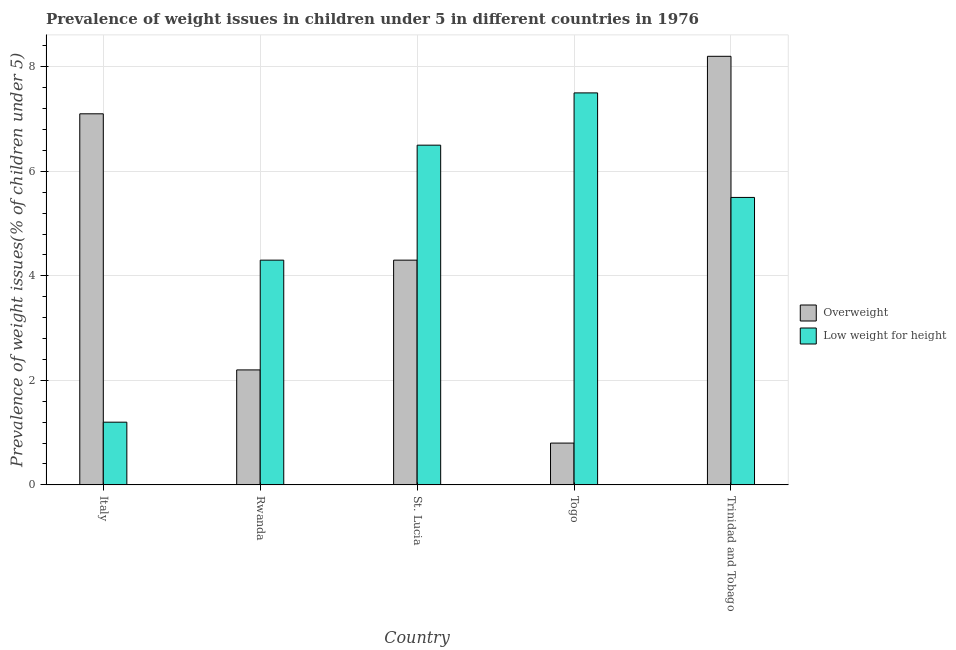How many groups of bars are there?
Ensure brevity in your answer.  5. Are the number of bars per tick equal to the number of legend labels?
Keep it short and to the point. Yes. Are the number of bars on each tick of the X-axis equal?
Your answer should be very brief. Yes. How many bars are there on the 4th tick from the right?
Your answer should be compact. 2. In how many cases, is the number of bars for a given country not equal to the number of legend labels?
Give a very brief answer. 0. Across all countries, what is the minimum percentage of overweight children?
Keep it short and to the point. 0.8. In which country was the percentage of overweight children maximum?
Ensure brevity in your answer.  Trinidad and Tobago. What is the total percentage of overweight children in the graph?
Provide a short and direct response. 22.6. What is the difference between the percentage of underweight children in Rwanda and that in Togo?
Ensure brevity in your answer.  -3.2. What is the difference between the percentage of underweight children in Italy and the percentage of overweight children in Trinidad and Tobago?
Make the answer very short. -7. What is the average percentage of underweight children per country?
Your response must be concise. 5. What is the difference between the percentage of overweight children and percentage of underweight children in Rwanda?
Provide a succinct answer. -2.1. What is the ratio of the percentage of overweight children in Italy to that in Trinidad and Tobago?
Your response must be concise. 0.87. Is the difference between the percentage of overweight children in Rwanda and Trinidad and Tobago greater than the difference between the percentage of underweight children in Rwanda and Trinidad and Tobago?
Your answer should be very brief. No. What is the difference between the highest and the second highest percentage of underweight children?
Provide a short and direct response. 1. What is the difference between the highest and the lowest percentage of overweight children?
Provide a short and direct response. 7.4. What does the 2nd bar from the left in Togo represents?
Ensure brevity in your answer.  Low weight for height. What does the 2nd bar from the right in Togo represents?
Your response must be concise. Overweight. Are all the bars in the graph horizontal?
Offer a terse response. No. How many countries are there in the graph?
Your answer should be compact. 5. Are the values on the major ticks of Y-axis written in scientific E-notation?
Provide a succinct answer. No. Does the graph contain grids?
Offer a very short reply. Yes. Where does the legend appear in the graph?
Offer a terse response. Center right. What is the title of the graph?
Provide a succinct answer. Prevalence of weight issues in children under 5 in different countries in 1976. Does "National Visitors" appear as one of the legend labels in the graph?
Your answer should be very brief. No. What is the label or title of the X-axis?
Your answer should be very brief. Country. What is the label or title of the Y-axis?
Provide a short and direct response. Prevalence of weight issues(% of children under 5). What is the Prevalence of weight issues(% of children under 5) in Overweight in Italy?
Your response must be concise. 7.1. What is the Prevalence of weight issues(% of children under 5) in Low weight for height in Italy?
Offer a terse response. 1.2. What is the Prevalence of weight issues(% of children under 5) of Overweight in Rwanda?
Keep it short and to the point. 2.2. What is the Prevalence of weight issues(% of children under 5) in Low weight for height in Rwanda?
Keep it short and to the point. 4.3. What is the Prevalence of weight issues(% of children under 5) of Overweight in St. Lucia?
Give a very brief answer. 4.3. What is the Prevalence of weight issues(% of children under 5) in Low weight for height in St. Lucia?
Your response must be concise. 6.5. What is the Prevalence of weight issues(% of children under 5) of Overweight in Togo?
Provide a succinct answer. 0.8. What is the Prevalence of weight issues(% of children under 5) of Overweight in Trinidad and Tobago?
Provide a succinct answer. 8.2. What is the Prevalence of weight issues(% of children under 5) in Low weight for height in Trinidad and Tobago?
Offer a very short reply. 5.5. Across all countries, what is the maximum Prevalence of weight issues(% of children under 5) of Overweight?
Your answer should be very brief. 8.2. Across all countries, what is the minimum Prevalence of weight issues(% of children under 5) in Overweight?
Your response must be concise. 0.8. Across all countries, what is the minimum Prevalence of weight issues(% of children under 5) of Low weight for height?
Make the answer very short. 1.2. What is the total Prevalence of weight issues(% of children under 5) in Overweight in the graph?
Offer a terse response. 22.6. What is the difference between the Prevalence of weight issues(% of children under 5) of Low weight for height in Italy and that in Rwanda?
Give a very brief answer. -3.1. What is the difference between the Prevalence of weight issues(% of children under 5) in Low weight for height in Italy and that in St. Lucia?
Make the answer very short. -5.3. What is the difference between the Prevalence of weight issues(% of children under 5) in Overweight in Italy and that in Togo?
Ensure brevity in your answer.  6.3. What is the difference between the Prevalence of weight issues(% of children under 5) in Low weight for height in Italy and that in Trinidad and Tobago?
Provide a succinct answer. -4.3. What is the difference between the Prevalence of weight issues(% of children under 5) in Overweight in Rwanda and that in St. Lucia?
Offer a terse response. -2.1. What is the difference between the Prevalence of weight issues(% of children under 5) of Overweight in Rwanda and that in Togo?
Give a very brief answer. 1.4. What is the difference between the Prevalence of weight issues(% of children under 5) in Overweight in Rwanda and that in Trinidad and Tobago?
Ensure brevity in your answer.  -6. What is the difference between the Prevalence of weight issues(% of children under 5) of Overweight in Italy and the Prevalence of weight issues(% of children under 5) of Low weight for height in St. Lucia?
Offer a terse response. 0.6. What is the difference between the Prevalence of weight issues(% of children under 5) in Overweight in Italy and the Prevalence of weight issues(% of children under 5) in Low weight for height in Togo?
Make the answer very short. -0.4. What is the difference between the Prevalence of weight issues(% of children under 5) in Overweight in Italy and the Prevalence of weight issues(% of children under 5) in Low weight for height in Trinidad and Tobago?
Keep it short and to the point. 1.6. What is the difference between the Prevalence of weight issues(% of children under 5) in Overweight in St. Lucia and the Prevalence of weight issues(% of children under 5) in Low weight for height in Togo?
Your answer should be compact. -3.2. What is the average Prevalence of weight issues(% of children under 5) in Overweight per country?
Your answer should be very brief. 4.52. What is the average Prevalence of weight issues(% of children under 5) of Low weight for height per country?
Make the answer very short. 5. What is the difference between the Prevalence of weight issues(% of children under 5) in Overweight and Prevalence of weight issues(% of children under 5) in Low weight for height in Italy?
Offer a very short reply. 5.9. What is the difference between the Prevalence of weight issues(% of children under 5) of Overweight and Prevalence of weight issues(% of children under 5) of Low weight for height in St. Lucia?
Ensure brevity in your answer.  -2.2. What is the difference between the Prevalence of weight issues(% of children under 5) in Overweight and Prevalence of weight issues(% of children under 5) in Low weight for height in Trinidad and Tobago?
Provide a succinct answer. 2.7. What is the ratio of the Prevalence of weight issues(% of children under 5) of Overweight in Italy to that in Rwanda?
Ensure brevity in your answer.  3.23. What is the ratio of the Prevalence of weight issues(% of children under 5) in Low weight for height in Italy to that in Rwanda?
Offer a terse response. 0.28. What is the ratio of the Prevalence of weight issues(% of children under 5) of Overweight in Italy to that in St. Lucia?
Offer a terse response. 1.65. What is the ratio of the Prevalence of weight issues(% of children under 5) in Low weight for height in Italy to that in St. Lucia?
Provide a succinct answer. 0.18. What is the ratio of the Prevalence of weight issues(% of children under 5) in Overweight in Italy to that in Togo?
Offer a very short reply. 8.88. What is the ratio of the Prevalence of weight issues(% of children under 5) in Low weight for height in Italy to that in Togo?
Provide a short and direct response. 0.16. What is the ratio of the Prevalence of weight issues(% of children under 5) in Overweight in Italy to that in Trinidad and Tobago?
Your answer should be very brief. 0.87. What is the ratio of the Prevalence of weight issues(% of children under 5) of Low weight for height in Italy to that in Trinidad and Tobago?
Offer a very short reply. 0.22. What is the ratio of the Prevalence of weight issues(% of children under 5) in Overweight in Rwanda to that in St. Lucia?
Ensure brevity in your answer.  0.51. What is the ratio of the Prevalence of weight issues(% of children under 5) of Low weight for height in Rwanda to that in St. Lucia?
Your response must be concise. 0.66. What is the ratio of the Prevalence of weight issues(% of children under 5) in Overweight in Rwanda to that in Togo?
Your answer should be very brief. 2.75. What is the ratio of the Prevalence of weight issues(% of children under 5) of Low weight for height in Rwanda to that in Togo?
Ensure brevity in your answer.  0.57. What is the ratio of the Prevalence of weight issues(% of children under 5) of Overweight in Rwanda to that in Trinidad and Tobago?
Provide a short and direct response. 0.27. What is the ratio of the Prevalence of weight issues(% of children under 5) in Low weight for height in Rwanda to that in Trinidad and Tobago?
Make the answer very short. 0.78. What is the ratio of the Prevalence of weight issues(% of children under 5) in Overweight in St. Lucia to that in Togo?
Offer a very short reply. 5.38. What is the ratio of the Prevalence of weight issues(% of children under 5) in Low weight for height in St. Lucia to that in Togo?
Your response must be concise. 0.87. What is the ratio of the Prevalence of weight issues(% of children under 5) of Overweight in St. Lucia to that in Trinidad and Tobago?
Keep it short and to the point. 0.52. What is the ratio of the Prevalence of weight issues(% of children under 5) of Low weight for height in St. Lucia to that in Trinidad and Tobago?
Your answer should be very brief. 1.18. What is the ratio of the Prevalence of weight issues(% of children under 5) in Overweight in Togo to that in Trinidad and Tobago?
Give a very brief answer. 0.1. What is the ratio of the Prevalence of weight issues(% of children under 5) in Low weight for height in Togo to that in Trinidad and Tobago?
Your answer should be compact. 1.36. 